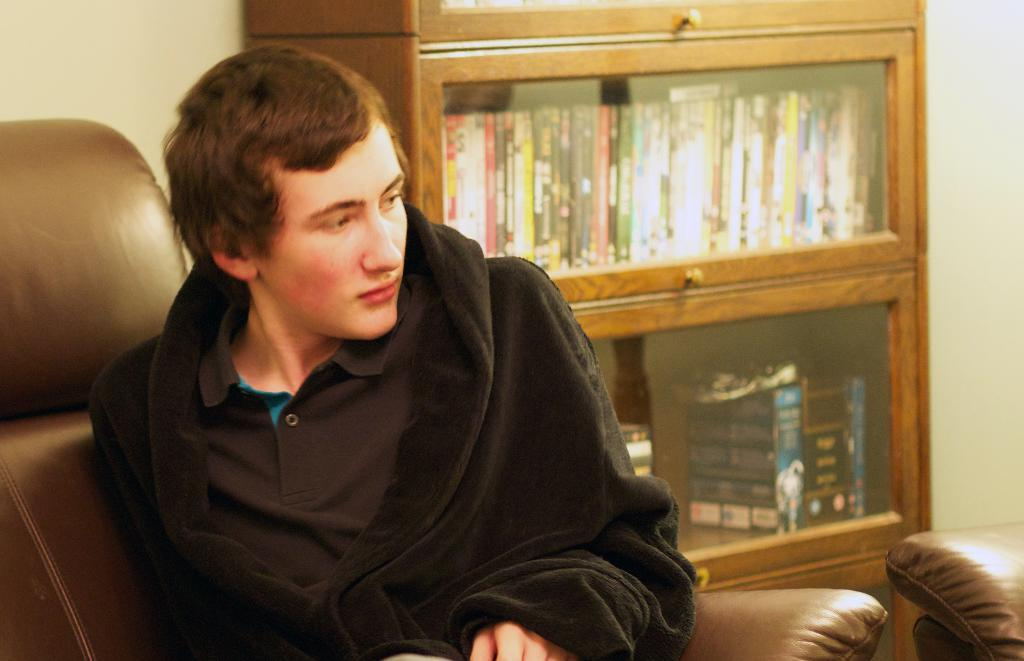What is the person in the image doing? There is a person sitting on a couch in the image. What can be seen in the background of the image? There is a rack filled with books and a wall in the background of the image. What is the purpose of the rack in the image? The rack is filled with books, suggesting it is used for storage or display of books. What type of quince is being served for lunch in the image? There is no quince or lunch present in the image. How many times does the person on the couch twist their body in the image? The person on the couch is sitting, so there is no twisting of the body in the image. 